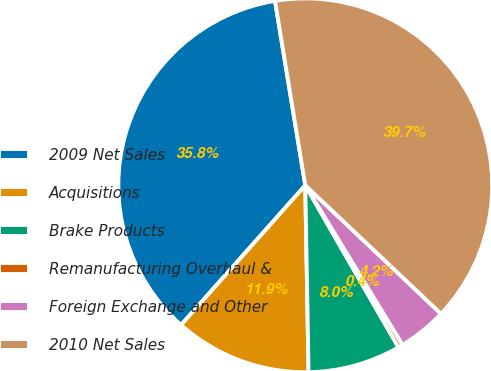<chart> <loc_0><loc_0><loc_500><loc_500><pie_chart><fcel>2009 Net Sales<fcel>Acquisitions<fcel>Brake Products<fcel>Remanufacturing Overhaul &<fcel>Foreign Exchange and Other<fcel>2010 Net Sales<nl><fcel>35.84%<fcel>11.85%<fcel>8.03%<fcel>0.41%<fcel>4.22%<fcel>39.65%<nl></chart> 